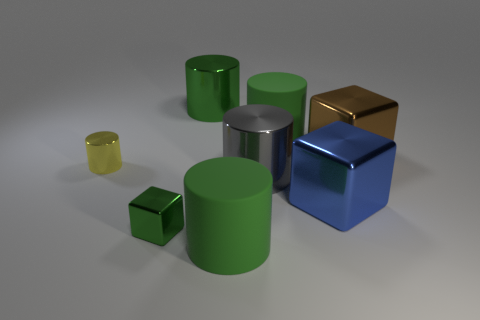Does the shiny thing behind the big brown shiny cube have the same color as the tiny metal block?
Your response must be concise. Yes. There is a matte cylinder on the left side of the big green matte cylinder that is on the right side of the big gray metallic thing; what color is it?
Provide a short and direct response. Green. What size is the green thing that is the same shape as the blue shiny object?
Offer a very short reply. Small. What number of large green rubber cylinders are behind the big matte cylinder that is in front of the blue shiny cube that is on the right side of the yellow metallic object?
Offer a very short reply. 1. Are there more large brown cylinders than big blue metal cubes?
Offer a very short reply. No. How many large metallic blocks are there?
Keep it short and to the point. 2. What shape is the green metallic object in front of the big cylinder left of the big green object that is in front of the brown shiny cube?
Offer a terse response. Cube. Is the number of green rubber objects left of the tiny green metal thing less than the number of big blue shiny cubes that are left of the small yellow shiny cylinder?
Keep it short and to the point. No. There is a large green matte thing behind the yellow metal cylinder; does it have the same shape as the small shiny thing that is right of the yellow cylinder?
Make the answer very short. No. There is a tiny metallic thing on the left side of the green metal thing that is on the left side of the large green metal thing; what shape is it?
Keep it short and to the point. Cylinder. 